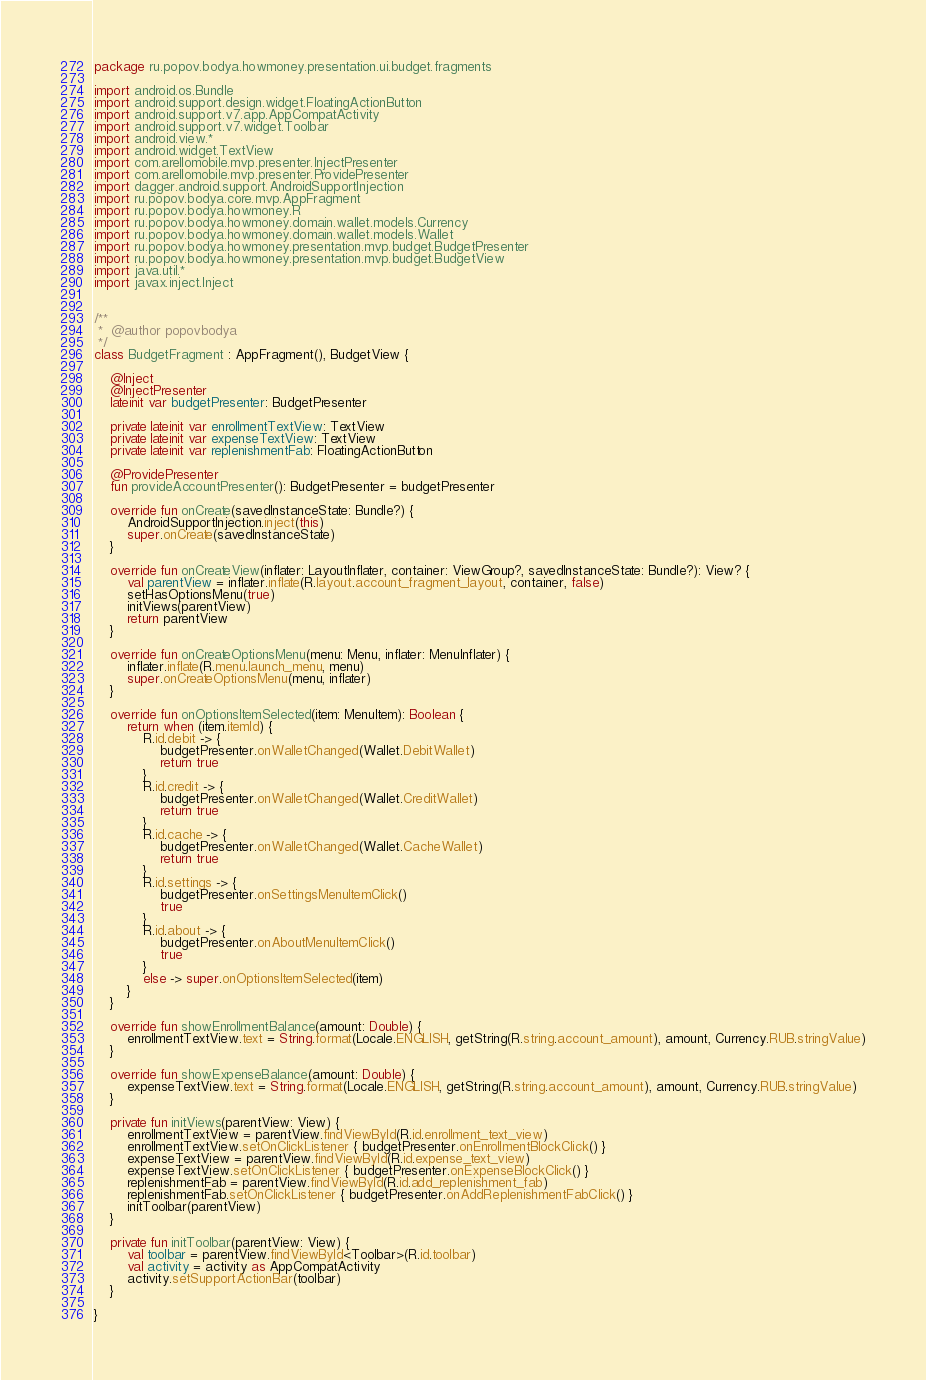<code> <loc_0><loc_0><loc_500><loc_500><_Kotlin_>package ru.popov.bodya.howmoney.presentation.ui.budget.fragments

import android.os.Bundle
import android.support.design.widget.FloatingActionButton
import android.support.v7.app.AppCompatActivity
import android.support.v7.widget.Toolbar
import android.view.*
import android.widget.TextView
import com.arellomobile.mvp.presenter.InjectPresenter
import com.arellomobile.mvp.presenter.ProvidePresenter
import dagger.android.support.AndroidSupportInjection
import ru.popov.bodya.core.mvp.AppFragment
import ru.popov.bodya.howmoney.R
import ru.popov.bodya.howmoney.domain.wallet.models.Currency
import ru.popov.bodya.howmoney.domain.wallet.models.Wallet
import ru.popov.bodya.howmoney.presentation.mvp.budget.BudgetPresenter
import ru.popov.bodya.howmoney.presentation.mvp.budget.BudgetView
import java.util.*
import javax.inject.Inject


/**
 *  @author popovbodya
 */
class BudgetFragment : AppFragment(), BudgetView {

    @Inject
    @InjectPresenter
    lateinit var budgetPresenter: BudgetPresenter

    private lateinit var enrollmentTextView: TextView
    private lateinit var expenseTextView: TextView
    private lateinit var replenishmentFab: FloatingActionButton

    @ProvidePresenter
    fun provideAccountPresenter(): BudgetPresenter = budgetPresenter

    override fun onCreate(savedInstanceState: Bundle?) {
        AndroidSupportInjection.inject(this)
        super.onCreate(savedInstanceState)
    }

    override fun onCreateView(inflater: LayoutInflater, container: ViewGroup?, savedInstanceState: Bundle?): View? {
        val parentView = inflater.inflate(R.layout.account_fragment_layout, container, false)
        setHasOptionsMenu(true)
        initViews(parentView)
        return parentView
    }

    override fun onCreateOptionsMenu(menu: Menu, inflater: MenuInflater) {
        inflater.inflate(R.menu.launch_menu, menu)
        super.onCreateOptionsMenu(menu, inflater)
    }

    override fun onOptionsItemSelected(item: MenuItem): Boolean {
        return when (item.itemId) {
            R.id.debit -> {
                budgetPresenter.onWalletChanged(Wallet.DebitWallet)
                return true
            }
            R.id.credit -> {
                budgetPresenter.onWalletChanged(Wallet.CreditWallet)
                return true
            }
            R.id.cache -> {
                budgetPresenter.onWalletChanged(Wallet.CacheWallet)
                return true
            }
            R.id.settings -> {
                budgetPresenter.onSettingsMenuItemClick()
                true
            }
            R.id.about -> {
                budgetPresenter.onAboutMenuItemClick()
                true
            }
            else -> super.onOptionsItemSelected(item)
        }
    }

    override fun showEnrollmentBalance(amount: Double) {
        enrollmentTextView.text = String.format(Locale.ENGLISH, getString(R.string.account_amount), amount, Currency.RUB.stringValue)
    }

    override fun showExpenseBalance(amount: Double) {
        expenseTextView.text = String.format(Locale.ENGLISH, getString(R.string.account_amount), amount, Currency.RUB.stringValue)
    }

    private fun initViews(parentView: View) {
        enrollmentTextView = parentView.findViewById(R.id.enrollment_text_view)
        enrollmentTextView.setOnClickListener { budgetPresenter.onEnrollmentBlockClick() }
        expenseTextView = parentView.findViewById(R.id.expense_text_view)
        expenseTextView.setOnClickListener { budgetPresenter.onExpenseBlockClick() }
        replenishmentFab = parentView.findViewById(R.id.add_replenishment_fab)
        replenishmentFab.setOnClickListener { budgetPresenter.onAddReplenishmentFabClick() }
        initToolbar(parentView)
    }

    private fun initToolbar(parentView: View) {
        val toolbar = parentView.findViewById<Toolbar>(R.id.toolbar)
        val activity = activity as AppCompatActivity
        activity.setSupportActionBar(toolbar)
    }

}</code> 